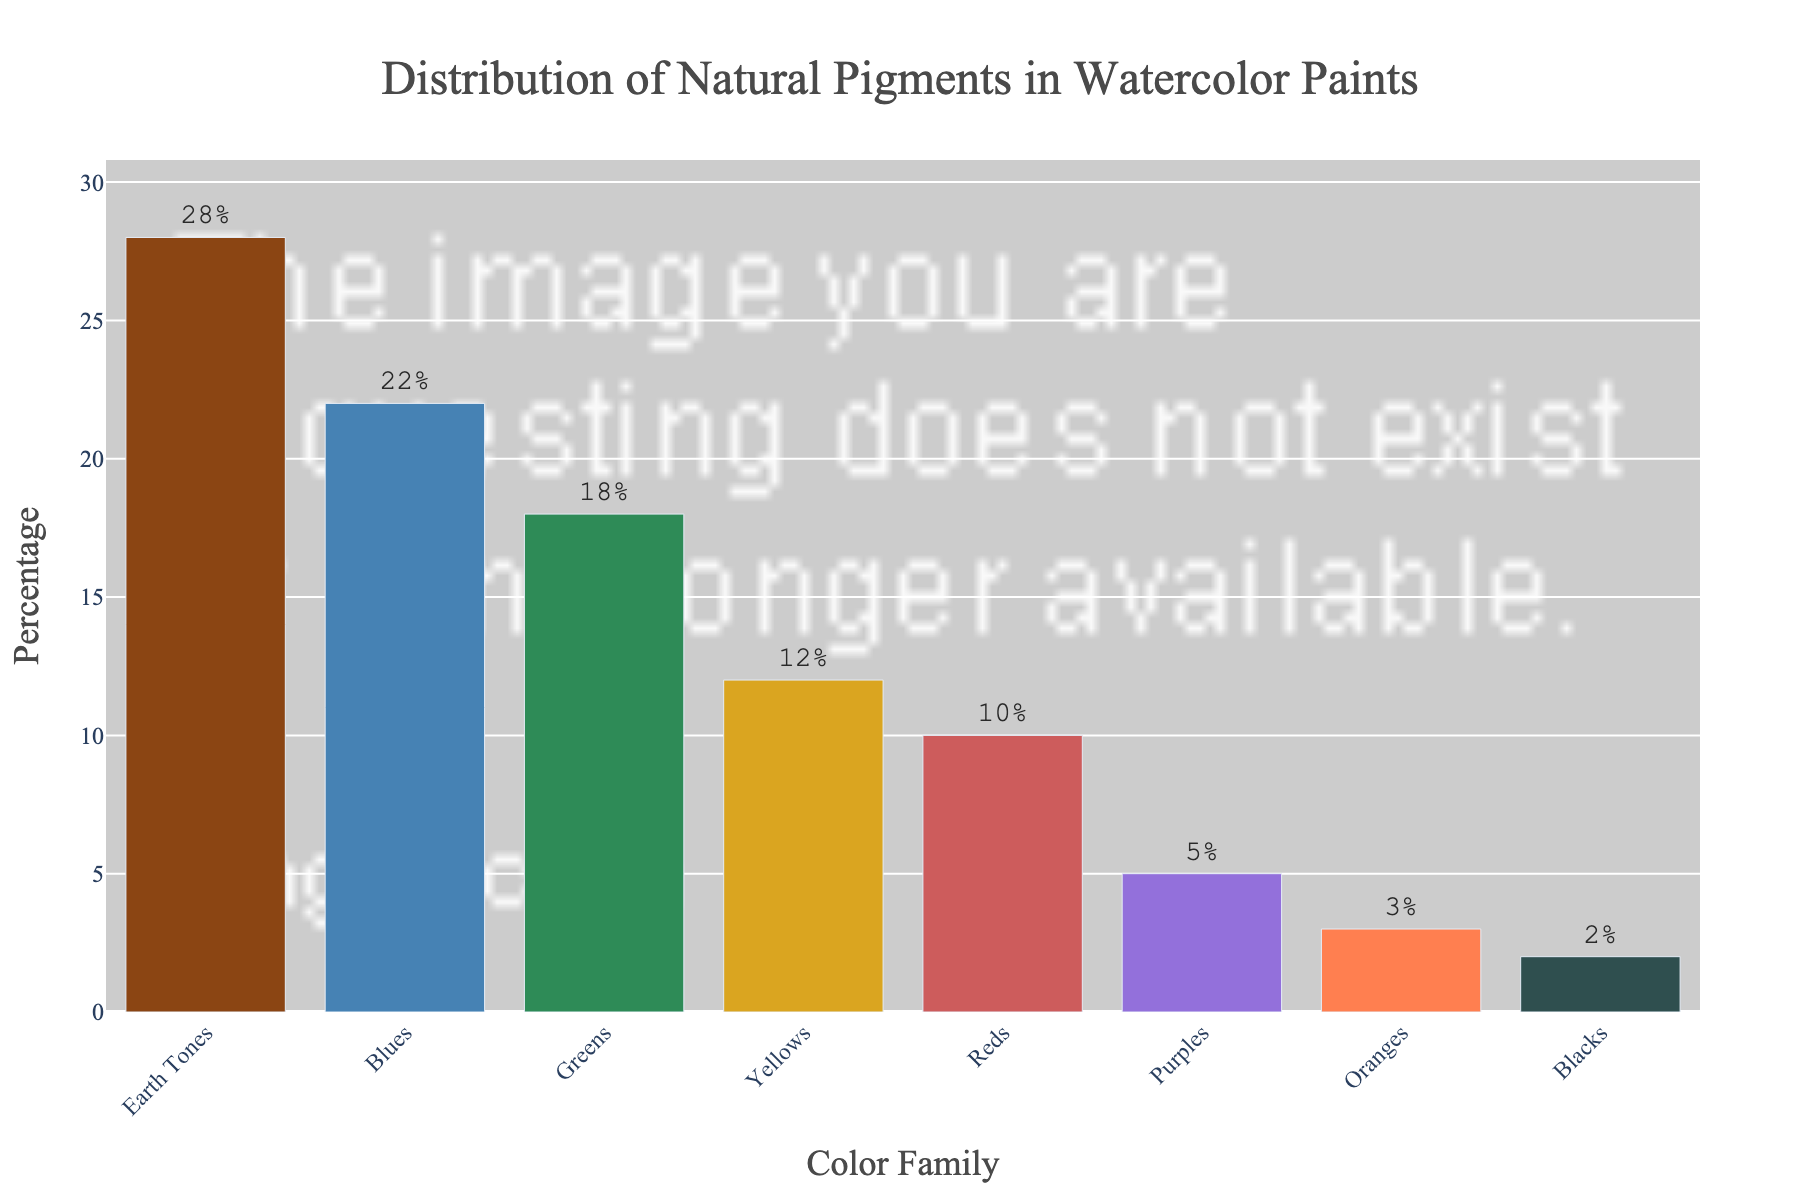What is the most used color family of natural pigments in watercolor paints? First, look at the height of each bar in the bar chart. The tallest bar represents the color family with the highest percentage. In this case, the tallest bar belongs to the 'Earth Tones' category, with a percentage of 28%.
Answer: Earth Tones Which color family has the lowest representation in natural pigments? Look for the shortest bar in the bar chart. The shortest bar corresponds to 'Blacks,' which has a percentage of 2%.
Answer: Blacks How much more are Earth Tones used compared to Reds? Identify the percentages of Earth Tones and Reds. Earth Tones have a percentage of 28%, while Reds have 10%. Subtract the percentage of Reds from that of Earth Tones: 28% - 10% = 18%.
Answer: 18% What is the combined percentage of Greens and Blues? Add the percentages of Greens and Blues. Greens have 18%, and Blues have 22%. So, 18% + 22% = 40%.
Answer: 40% Which color family has a usage percentage closest to the average usage of all color families? Calculate the average percentage first. (28% + 22% + 18% + 12% + 10% + 5% + 3% + 2%) / 8 = 100% / 8 = 12.5%. Check which color family’s percentage is closest to 12.5%; 'Yellows' have 12%, which is the closest.
Answer: Yellows Between Blues and Greens, which color family has a higher percentage and by how much? Look at the percentages of Blues and Greens. Blues have 22%, and Greens have 18%. The difference is 22% - 18% = 4%.
Answer: Blues; 4% If the percentages of Yellows and Oranges were combined, would their total be greater than or less than Greens? First, add the percentages of Yellows and Oranges: 12% + 3% = 15%. Then, compare it with the percentage of Greens, which is 18%. Since 15% is less than 18%, their combined total would be less than Greens.
Answer: Less than What is the visual difference in height between the bars representing Purples and Oranges? Compare the heights of the bars for Purples and Oranges. Purples have a percentage of 5%, and Oranges have 3%. So, the visual difference in height is 5% - 3% = 2%.
Answer: 2% Is the total usage percentage of Reds and Purples greater than or less than Blues? Sum the percentages of Reds and Purples: 10% + 5% = 15%. Compare it to the percentage of Blues, which is 22%. Since 15% is less than 22%, the total usage percentage of Reds and Purples is less than Blues.
Answer: Less than What percentage of natural pigments is represented by color families other than Earth Tones? Subtract the percentage of Earth Tones from 100% to find the remaining share: 100% - 28% = 72%.
Answer: 72% 